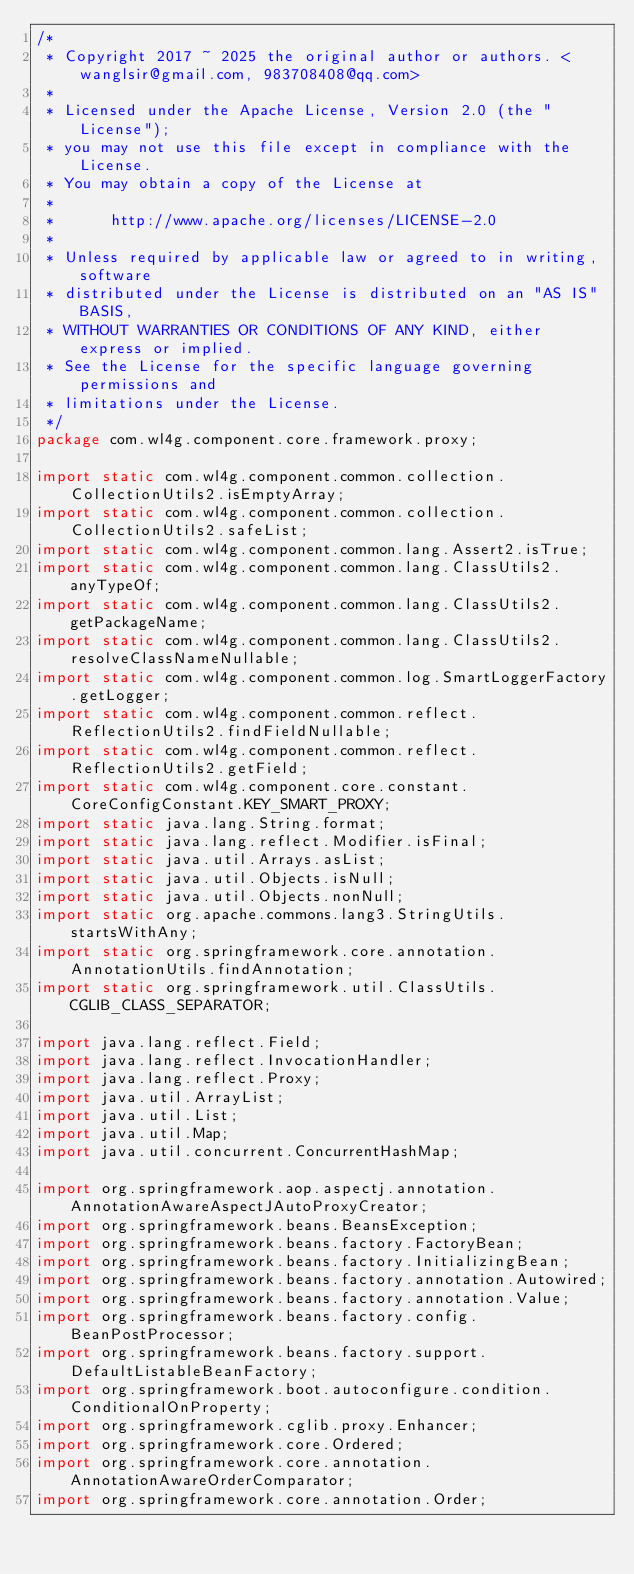<code> <loc_0><loc_0><loc_500><loc_500><_Java_>/*
 * Copyright 2017 ~ 2025 the original author or authors. <wanglsir@gmail.com, 983708408@qq.com>
 *
 * Licensed under the Apache License, Version 2.0 (the "License");
 * you may not use this file except in compliance with the License.
 * You may obtain a copy of the License at
 *
 *      http://www.apache.org/licenses/LICENSE-2.0
 *
 * Unless required by applicable law or agreed to in writing, software
 * distributed under the License is distributed on an "AS IS" BASIS,
 * WITHOUT WARRANTIES OR CONDITIONS OF ANY KIND, either express or implied.
 * See the License for the specific language governing permissions and
 * limitations under the License.
 */
package com.wl4g.component.core.framework.proxy;

import static com.wl4g.component.common.collection.CollectionUtils2.isEmptyArray;
import static com.wl4g.component.common.collection.CollectionUtils2.safeList;
import static com.wl4g.component.common.lang.Assert2.isTrue;
import static com.wl4g.component.common.lang.ClassUtils2.anyTypeOf;
import static com.wl4g.component.common.lang.ClassUtils2.getPackageName;
import static com.wl4g.component.common.lang.ClassUtils2.resolveClassNameNullable;
import static com.wl4g.component.common.log.SmartLoggerFactory.getLogger;
import static com.wl4g.component.common.reflect.ReflectionUtils2.findFieldNullable;
import static com.wl4g.component.common.reflect.ReflectionUtils2.getField;
import static com.wl4g.component.core.constant.CoreConfigConstant.KEY_SMART_PROXY;
import static java.lang.String.format;
import static java.lang.reflect.Modifier.isFinal;
import static java.util.Arrays.asList;
import static java.util.Objects.isNull;
import static java.util.Objects.nonNull;
import static org.apache.commons.lang3.StringUtils.startsWithAny;
import static org.springframework.core.annotation.AnnotationUtils.findAnnotation;
import static org.springframework.util.ClassUtils.CGLIB_CLASS_SEPARATOR;

import java.lang.reflect.Field;
import java.lang.reflect.InvocationHandler;
import java.lang.reflect.Proxy;
import java.util.ArrayList;
import java.util.List;
import java.util.Map;
import java.util.concurrent.ConcurrentHashMap;

import org.springframework.aop.aspectj.annotation.AnnotationAwareAspectJAutoProxyCreator;
import org.springframework.beans.BeansException;
import org.springframework.beans.factory.FactoryBean;
import org.springframework.beans.factory.InitializingBean;
import org.springframework.beans.factory.annotation.Autowired;
import org.springframework.beans.factory.annotation.Value;
import org.springframework.beans.factory.config.BeanPostProcessor;
import org.springframework.beans.factory.support.DefaultListableBeanFactory;
import org.springframework.boot.autoconfigure.condition.ConditionalOnProperty;
import org.springframework.cglib.proxy.Enhancer;
import org.springframework.core.Ordered;
import org.springframework.core.annotation.AnnotationAwareOrderComparator;
import org.springframework.core.annotation.Order;</code> 